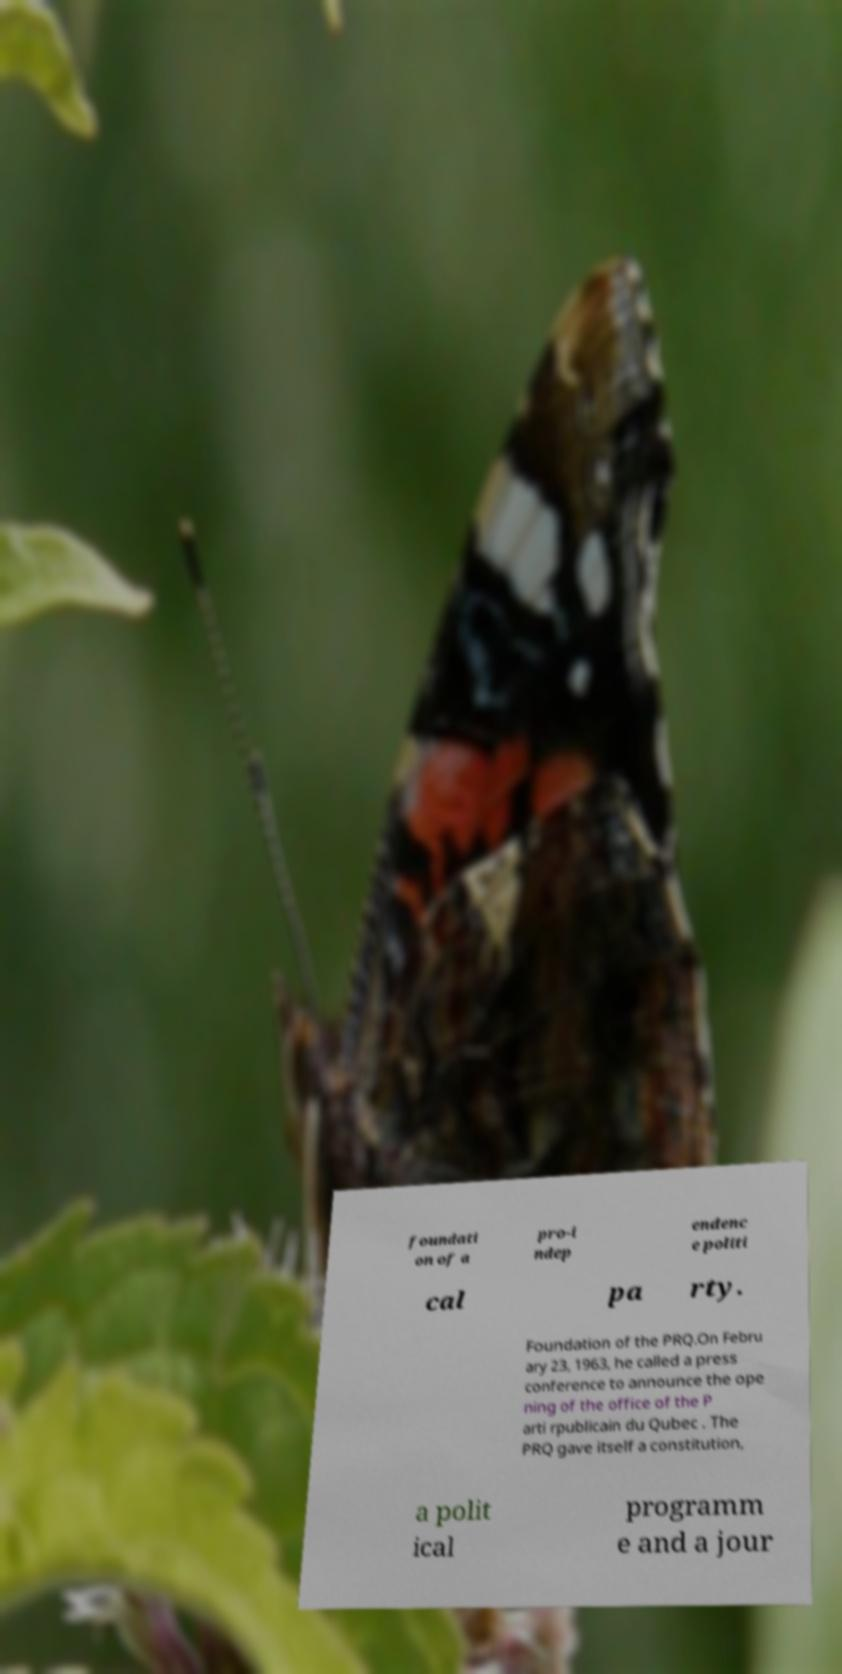There's text embedded in this image that I need extracted. Can you transcribe it verbatim? foundati on of a pro-i ndep endenc e politi cal pa rty. Foundation of the PRQ.On Febru ary 23, 1963, he called a press conference to announce the ope ning of the office of the P arti rpublicain du Qubec . The PRQ gave itself a constitution, a polit ical programm e and a jour 